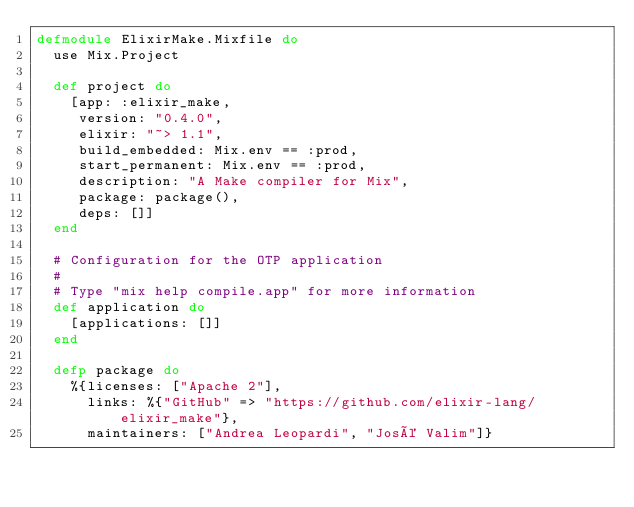Convert code to text. <code><loc_0><loc_0><loc_500><loc_500><_Elixir_>defmodule ElixirMake.Mixfile do
  use Mix.Project

  def project do
    [app: :elixir_make,
     version: "0.4.0",
     elixir: "~> 1.1",
     build_embedded: Mix.env == :prod,
     start_permanent: Mix.env == :prod,
     description: "A Make compiler for Mix",
     package: package(),
     deps: []]
  end

  # Configuration for the OTP application
  #
  # Type "mix help compile.app" for more information
  def application do
    [applications: []]
  end

  defp package do
    %{licenses: ["Apache 2"],
      links: %{"GitHub" => "https://github.com/elixir-lang/elixir_make"},
      maintainers: ["Andrea Leopardi", "José Valim"]}</code> 